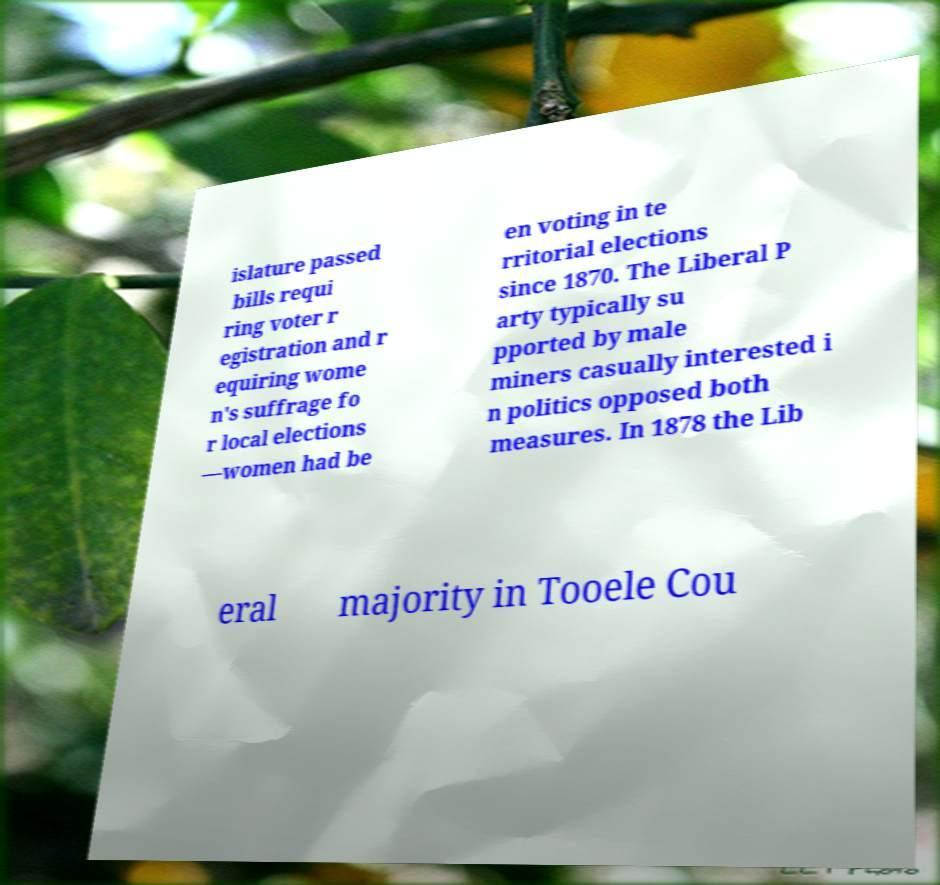Can you accurately transcribe the text from the provided image for me? islature passed bills requi ring voter r egistration and r equiring wome n's suffrage fo r local elections —women had be en voting in te rritorial elections since 1870. The Liberal P arty typically su pported by male miners casually interested i n politics opposed both measures. In 1878 the Lib eral majority in Tooele Cou 